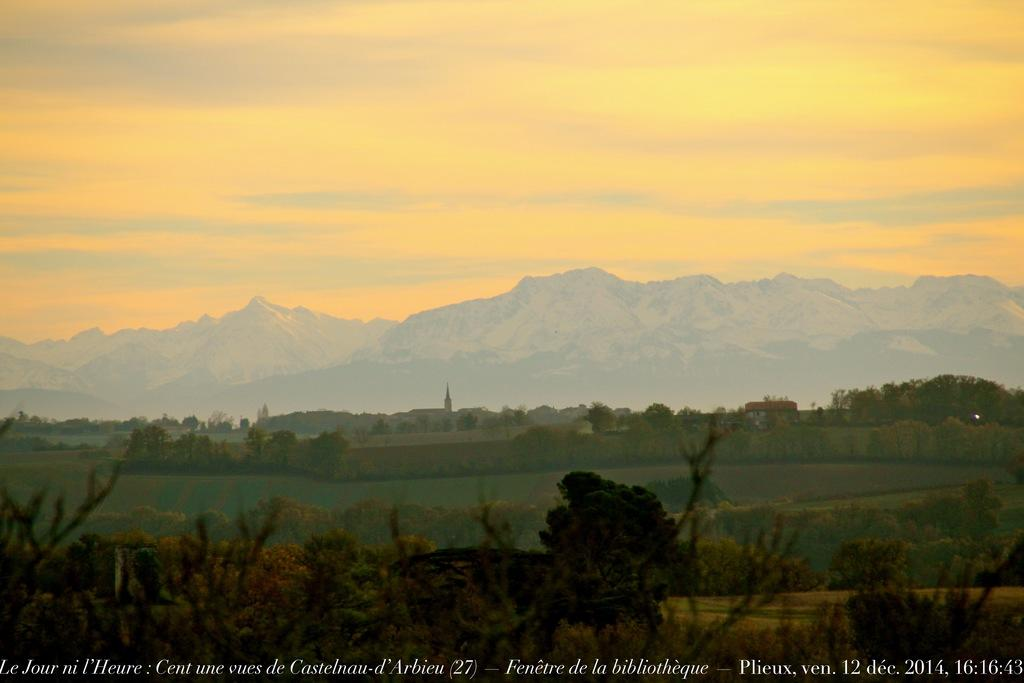What type of natural environment is visible at the bottom side of the image? There is greenery at the bottom side of the image. What part of the natural environment is visible at the top side of the image? The sky is visible at the top side of the image. Can you see a tramp in the image? There is no tramp present in the image. Is there a ghost visible in the greenery at the bottom side of the image? There is no ghost present in the image. 